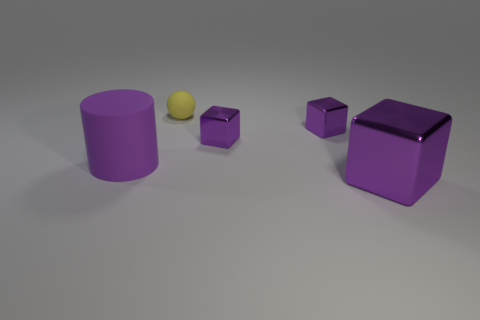What number of metal things are in front of the tiny sphere? There appear to be three metal-looking objects positioned in front of the small yellow sphere; one cylinder and two cubes. 